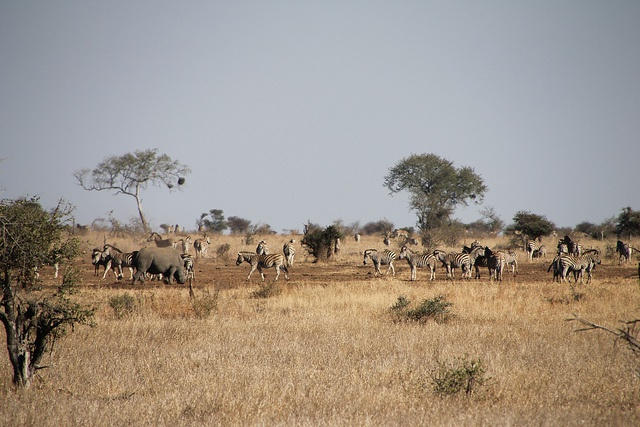Describe the objects in this image and their specific colors. I can see zebra in gray, black, and maroon tones, zebra in gray, black, and tan tones, zebra in gray, black, and tan tones, zebra in gray, tan, and black tones, and zebra in gray, tan, and black tones in this image. 